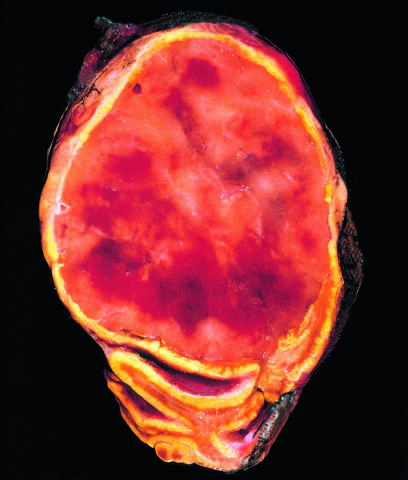re granules containing catecholamine not visible in this preparation?
Answer the question using a single word or phrase. Yes 